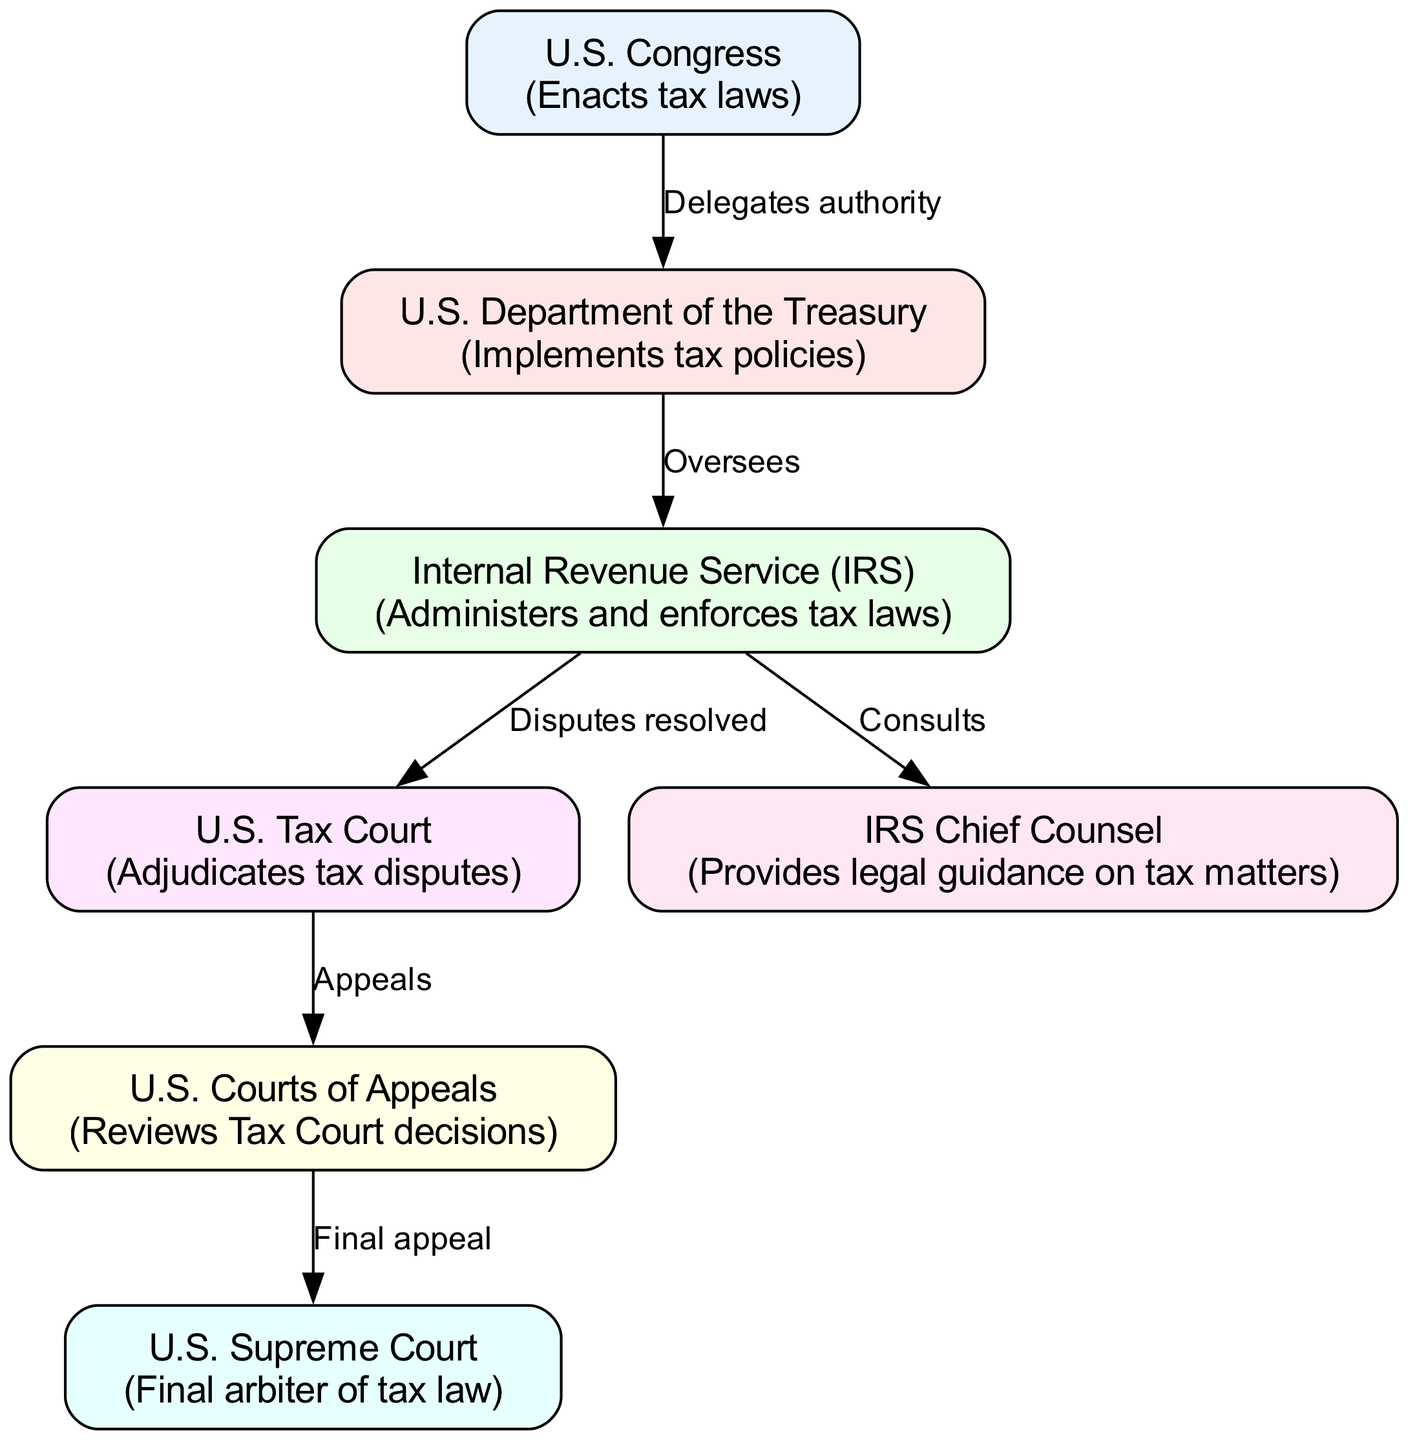What is the role of the U.S. Congress? The U.S. Congress is responsible for enacting tax laws, as indicated in the description of the node labeled 'U.S. Congress'.
Answer: Enacts tax laws Which entity implements tax policies? According to the diagram, the U.S. Department of the Treasury is described as the entity that implements tax policies.
Answer: U.S. Department of the Treasury How many nodes are there in the diagram? By counting the nodes provided in the data, there are a total of seven nodes represented in the diagram.
Answer: Seven What does the IRS Chief Counsel provide? The node labeled 'IRS Chief Counsel' indicates that it provides legal guidance on tax matters, which directly answers the question.
Answer: Legal guidance on tax matters What is the final arbiter of tax law? The diagram specifies that the U.S. Supreme Court is the final arbiter of tax law, directly answering the question based on the corresponding node.
Answer: U.S. Supreme Court What relationship does the U.S. Congress have with the U.S. Department of the Treasury? The diagram shows that the U.S. Congress delegates authority to the U.S. Department of the Treasury, indicating a flow of power and responsibility.
Answer: Delegates authority Which court reviews Tax Court decisions? In the diagram, it is evident that the U.S. Courts of Appeals reviews decisions made by the Tax Court, directly answering the question based on the flow in the edges.
Answer: U.S. Courts of Appeals How do tax disputes get resolved according to the diagram? The diagram states that the IRS disputes are resolved through the U.S. Tax Court, indicating the process for resolving tax disputes.
Answer: U.S. Tax Court What happens after a decision is made by the U.S. Tax Court? According to the diagram, decisions made by the U.S. Tax Court can be appealed, which shows the flow of dispute resolution in the tax system.
Answer: Appeals What is the purpose of the edge connecting the IRS to its Chief Counsel? The diagram indicates that the IRS consults with its Chief Counsel to obtain legal guidance on tax matters, clarifying the purpose of that edge.
Answer: Consults 